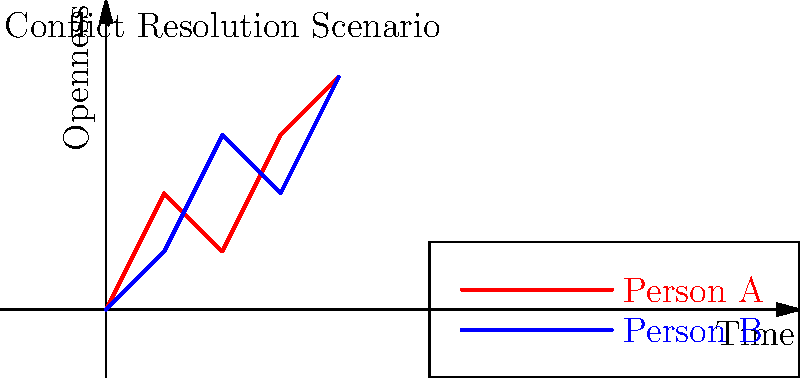In the conflict resolution scenario depicted above, which person's body language suggests a more cooperative approach over time? To interpret the body language in this conflict resolution scenario, we need to analyze the trends shown in the graph:

1. The x-axis represents time, while the y-axis represents openness in body language.
2. Two lines are shown: red for Person A and blue for Person B.
3. Person A's line (red):
   - Starts high but fluctuates
   - Shows an overall upward trend
4. Person B's line (blue):
   - Starts lower but steadily increases
   - Shows a more consistent upward trend

5. In conflict resolution, consistent increase in openness is generally more conducive to cooperation.
6. Person B's steady increase in openness suggests a more reliable progression towards cooperation.
7. Person A, while ending at a high point, shows inconsistency which might indicate less stability in their approach.

Therefore, based on the graph, Person B's body language suggests a more cooperative approach over time due to the steady and consistent increase in openness.
Answer: Person B 